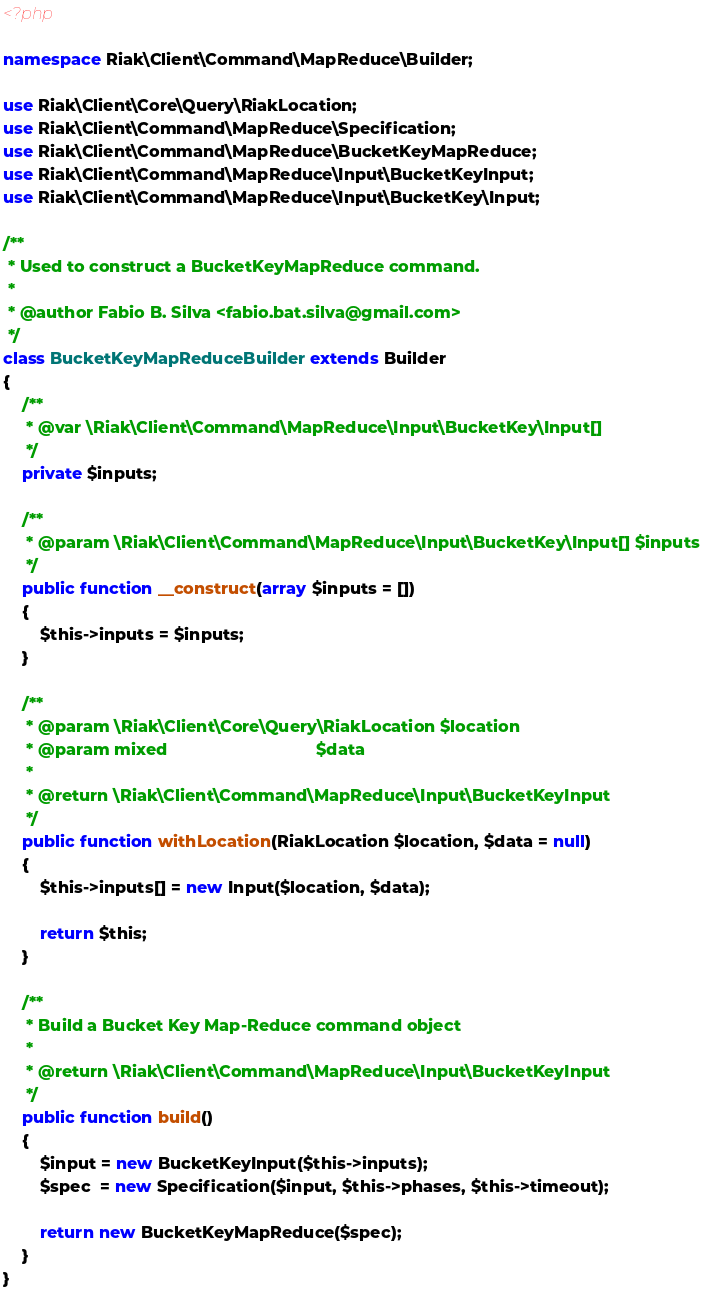<code> <loc_0><loc_0><loc_500><loc_500><_PHP_><?php

namespace Riak\Client\Command\MapReduce\Builder;

use Riak\Client\Core\Query\RiakLocation;
use Riak\Client\Command\MapReduce\Specification;
use Riak\Client\Command\MapReduce\BucketKeyMapReduce;
use Riak\Client\Command\MapReduce\Input\BucketKeyInput;
use Riak\Client\Command\MapReduce\Input\BucketKey\Input;

/**
 * Used to construct a BucketKeyMapReduce command.
 *
 * @author Fabio B. Silva <fabio.bat.silva@gmail.com>
 */
class BucketKeyMapReduceBuilder extends Builder
{
    /**
     * @var \Riak\Client\Command\MapReduce\Input\BucketKey\Input[]
     */
    private $inputs;

    /**
     * @param \Riak\Client\Command\MapReduce\Input\BucketKey\Input[] $inputs
     */
    public function __construct(array $inputs = [])
    {
        $this->inputs = $inputs;
    }

    /**
     * @param \Riak\Client\Core\Query\RiakLocation $location
     * @param mixed                                $data
     *
     * @return \Riak\Client\Command\MapReduce\Input\BucketKeyInput
     */
    public function withLocation(RiakLocation $location, $data = null)
    {
        $this->inputs[] = new Input($location, $data);

        return $this;
    }

    /**
     * Build a Bucket Key Map-Reduce command object
     *
     * @return \Riak\Client\Command\MapReduce\Input\BucketKeyInput
     */
    public function build()
    {
        $input = new BucketKeyInput($this->inputs);
        $spec  = new Specification($input, $this->phases, $this->timeout);

        return new BucketKeyMapReduce($spec);
    }
}
</code> 